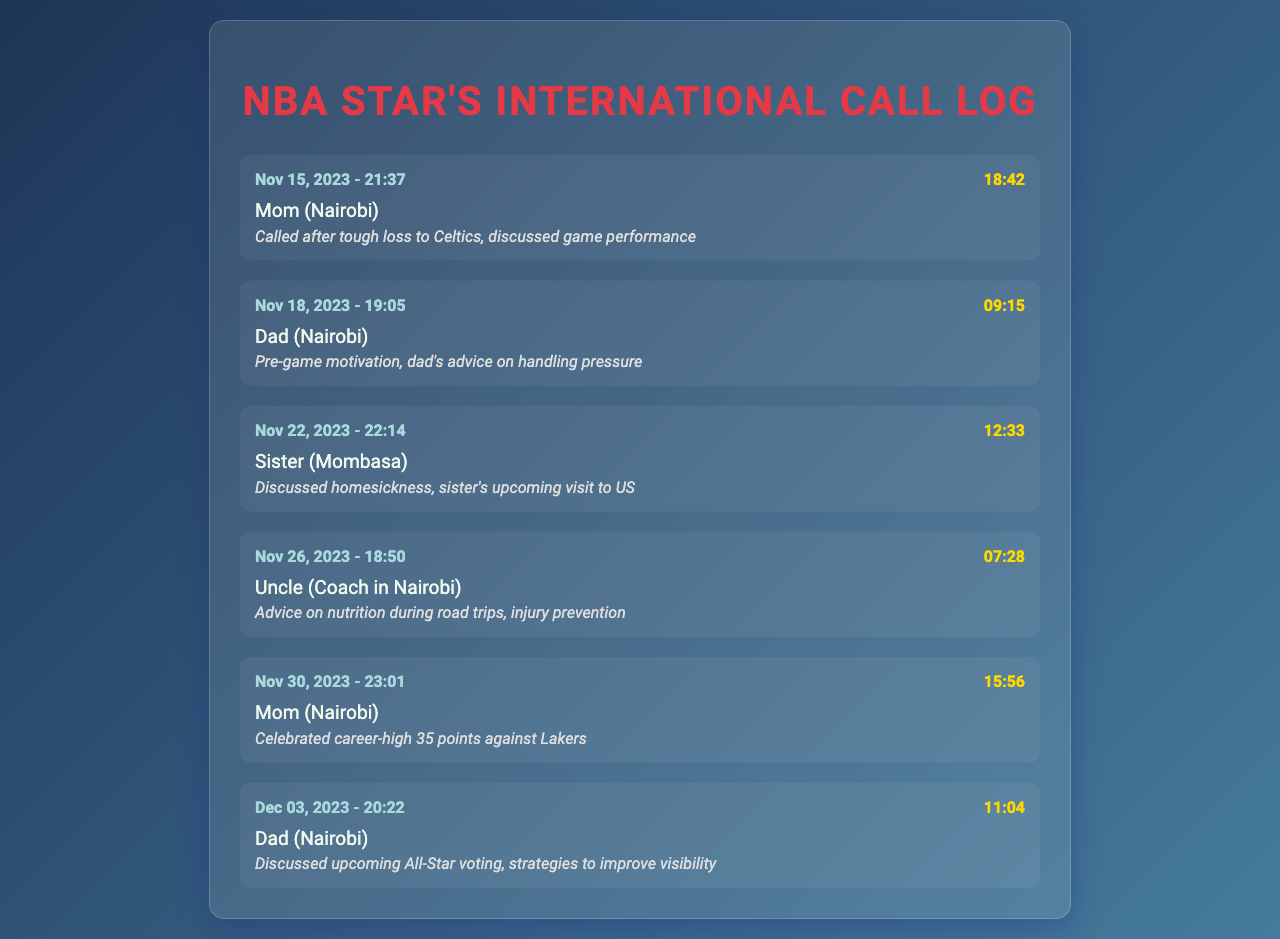What date did the call to Mom occur after the loss to the Celtics? The call to Mom occurred on November 15, 2023, after a tough game against the Celtics.
Answer: November 15, 2023 How long was the call with Dad on November 18, 2023? The duration of the call with Dad on November 18, 2023, was noted in the log as 9 minutes and 15 seconds.
Answer: 9:15 Who did the NBA player speak to about homesickness? The call log indicates that the player discussed homesickness with his sister on November 22, 2023.
Answer: Sister What was the main topic of the call with Uncle (Coach in Nairobi)? The call with Uncle revolved around advice on nutrition during road trips and injury prevention, showing a focus on health and fitness.
Answer: Nutrition and injury prevention How many calls were made to family members documented in the log? The log contains a record of six international calls made to family members for emotional support.
Answer: 6 Which family member was called to celebrate the career-high of 35 points? The call celebrating the career-high was made to Mom on November 30, 2023, highlighting a personal achievement.
Answer: Mom What was discussed during the call with Dad on December 3, 2023? The call with Dad involved a conversation about upcoming All-Star voting and strategies to improve visibility.
Answer: All-Star voting and visibility strategies What time was the call made to Sister on November 22, 2023? The call to Sister on November 22, 2023, was made at 22:14, showing the time of the connection.
Answer: 22:14 Which family member provided motivational advice before a game? Dad provided pre-game motivation on November 18, 2023, demonstrating his supportive role.
Answer: Dad 